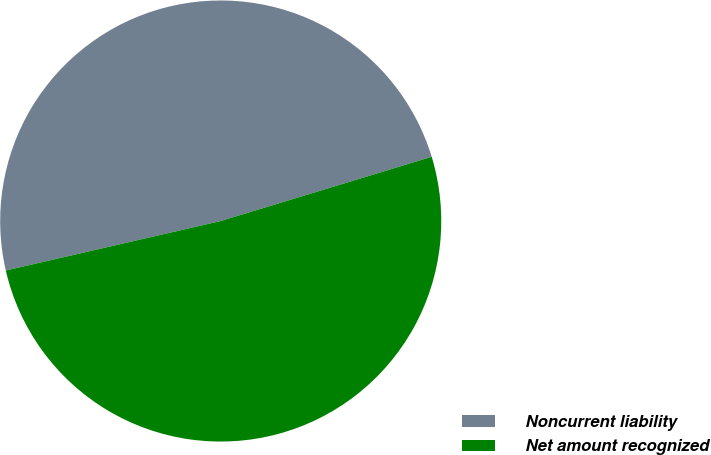Convert chart. <chart><loc_0><loc_0><loc_500><loc_500><pie_chart><fcel>Noncurrent liability<fcel>Net amount recognized<nl><fcel>48.9%<fcel>51.1%<nl></chart> 